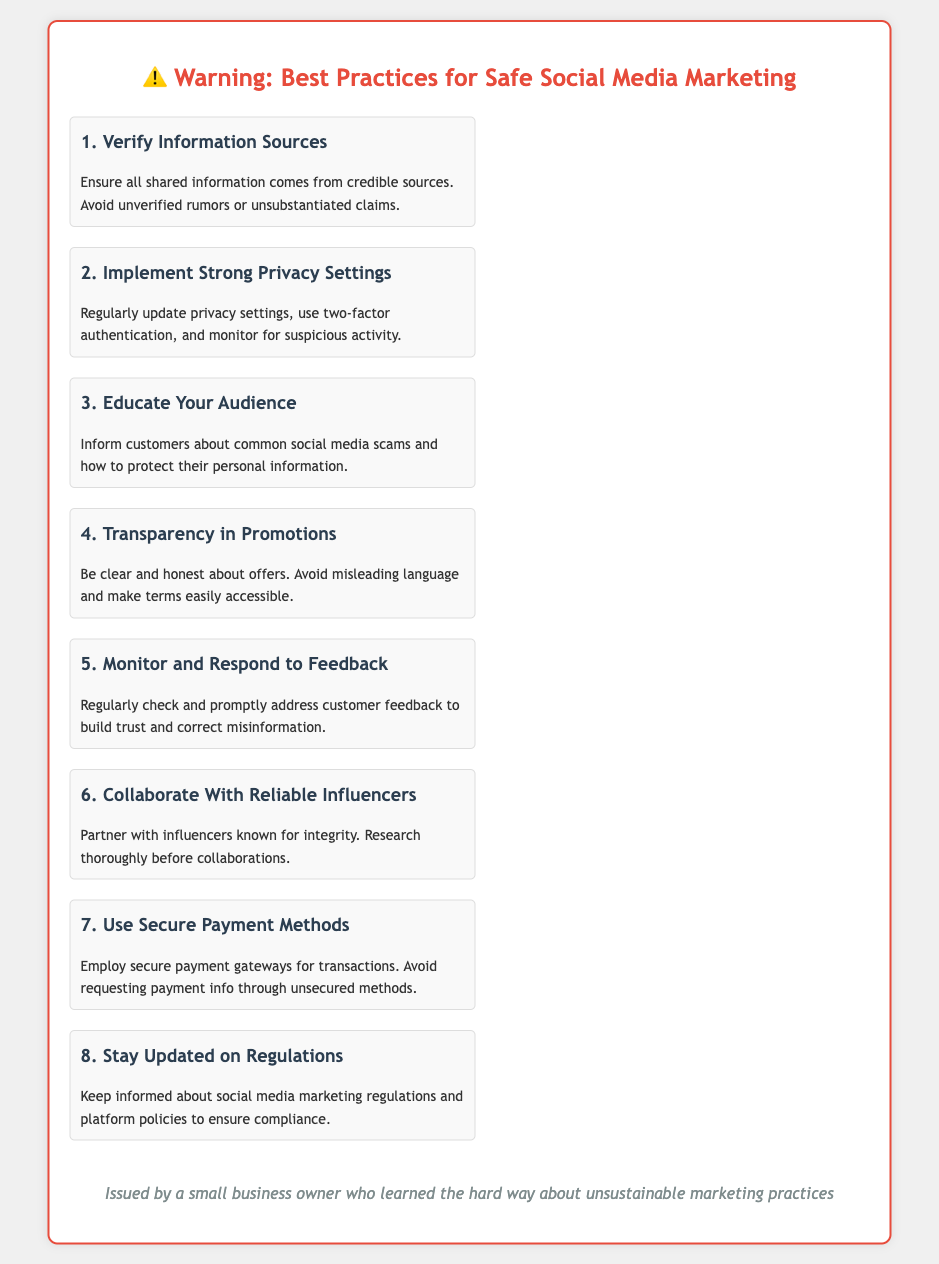What is the first best practice mentioned? The first best practice listed in the document is about verifying information sources to ensure credibility.
Answer: Verify Information Sources How many best practices are listed? The document includes a total of eight best practices for safe social media marketing.
Answer: 8 What should be implemented for better privacy? The document advises implementing strong privacy settings and includes practices like updating settings and using two-factor authentication.
Answer: Strong Privacy Settings What is recommended to educate customers about? The document mentions educating your audience about common social media scams and how to protect their personal information.
Answer: Common social media scams Who should you collaborate with for safer marketing? The document suggests collaborating with reliable influencers known for their integrity.
Answer: Reliable influencers What is emphasized regarding promotional offers? The document highlights the importance of transparency in promotions by being clear and honest about offers.
Answer: Transparency in Promotions What is the purpose of monitoring and responding to feedback? The document states that monitoring and responding to feedback helps to build trust and correct misinformation.
Answer: Build trust and correct misinformation What is advised to ensure secure transactions? The document recommends using secure payment methods and avoiding unsecured payment requests.
Answer: Secure payment methods 